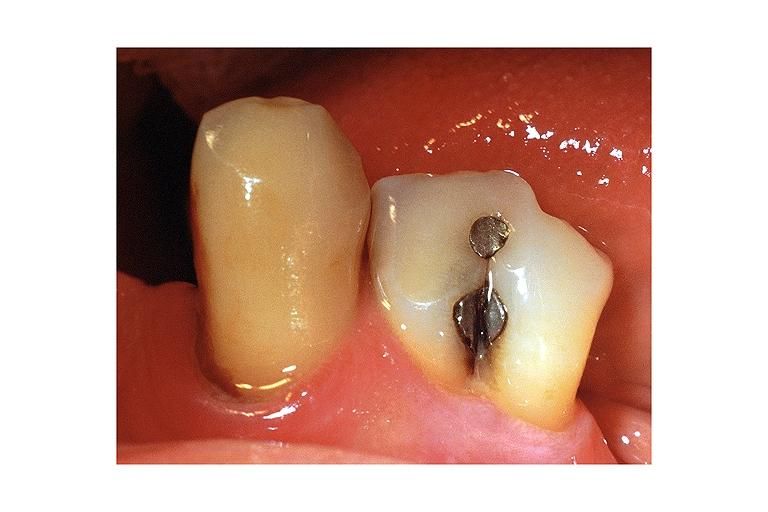s excellent example present?
Answer the question using a single word or phrase. No 